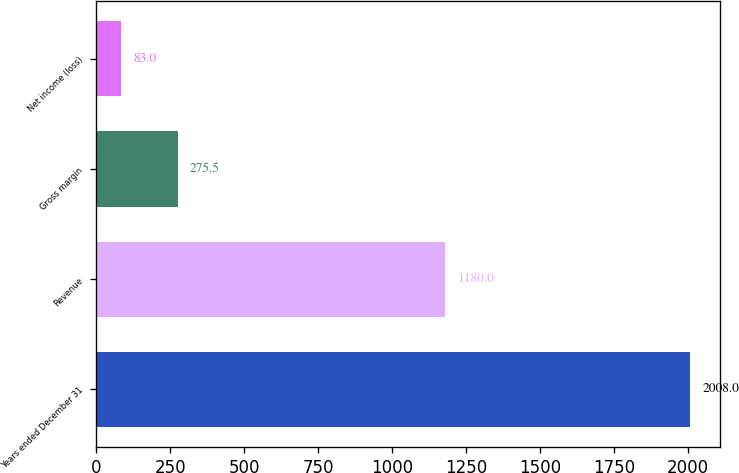Convert chart to OTSL. <chart><loc_0><loc_0><loc_500><loc_500><bar_chart><fcel>Years ended December 31<fcel>Revenue<fcel>Gross margin<fcel>Net income (loss)<nl><fcel>2008<fcel>1180<fcel>275.5<fcel>83<nl></chart> 